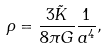<formula> <loc_0><loc_0><loc_500><loc_500>\rho = \frac { 3 \tilde { K } } { 8 \pi G } \frac { 1 } { a ^ { 4 } } ,</formula> 